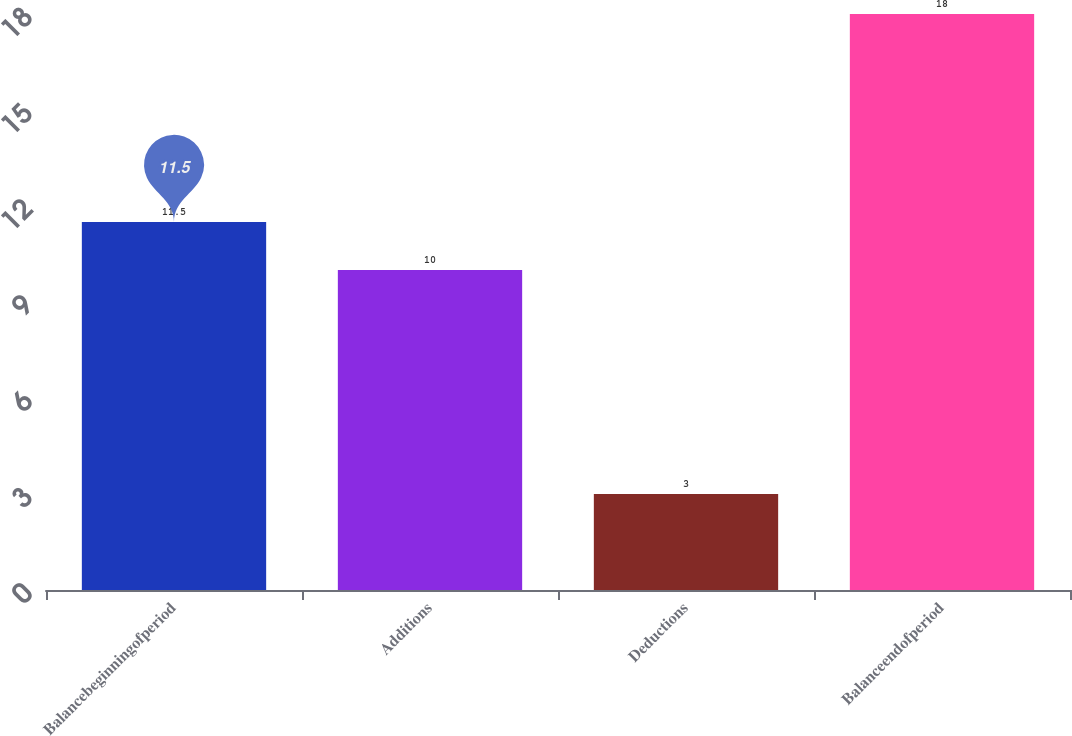Convert chart. <chart><loc_0><loc_0><loc_500><loc_500><bar_chart><fcel>Balancebeginningofperiod<fcel>Additions<fcel>Deductions<fcel>Balanceendofperiod<nl><fcel>11.5<fcel>10<fcel>3<fcel>18<nl></chart> 